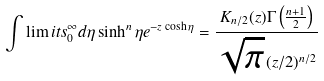Convert formula to latex. <formula><loc_0><loc_0><loc_500><loc_500>\int \lim i t s _ { 0 } ^ { \infty } d \eta \sinh ^ { n } \eta e ^ { - z \cosh \eta } = \frac { K _ { n / 2 } ( z ) \Gamma \left ( \frac { n + 1 } 2 \right ) } { \sqrt { \pi } \, ( z / 2 ) ^ { n / 2 } }</formula> 